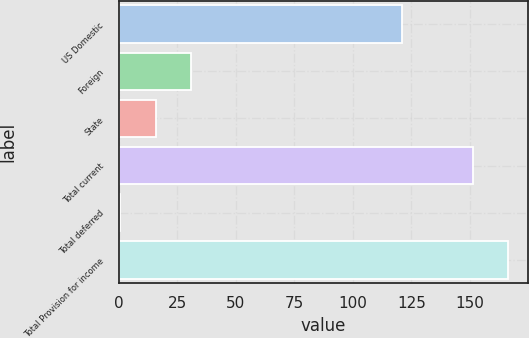Convert chart. <chart><loc_0><loc_0><loc_500><loc_500><bar_chart><fcel>US Domestic<fcel>Foreign<fcel>State<fcel>Total current<fcel>Total deferred<fcel>Total Provision for income<nl><fcel>120.8<fcel>30.84<fcel>15.72<fcel>151.2<fcel>0.6<fcel>166.32<nl></chart> 